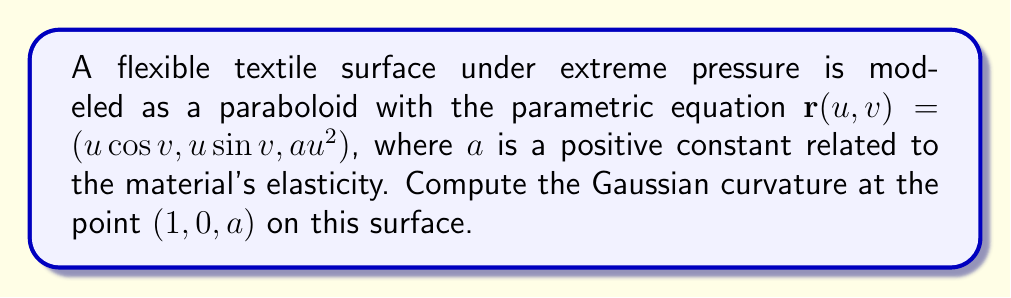What is the answer to this math problem? To compute the Gaussian curvature, we'll follow these steps:

1) First, we need to calculate the first fundamental form coefficients:
   $E = \mathbf{r}_u \cdot \mathbf{r}_u$, $F = \mathbf{r}_u \cdot \mathbf{r}_v$, $G = \mathbf{r}_v \cdot \mathbf{r}_v$

2) Then, we'll calculate the second fundamental form coefficients:
   $e = \mathbf{n} \cdot \mathbf{r}_{uu}$, $f = \mathbf{n} \cdot \mathbf{r}_{uv}$, $g = \mathbf{n} \cdot \mathbf{r}_{vv}$

3) Finally, we'll use the formula for Gaussian curvature:
   $K = \frac{eg-f^2}{EG-F^2}$

Step 1: Calculating first fundamental form coefficients

$\mathbf{r}_u = (\cos v, \sin v, 2au)$
$\mathbf{r}_v = (-u\sin v, u\cos v, 0)$

$E = \cos^2 v + \sin^2 v + 4a^2u^2 = 1 + 4a^2u^2$
$F = -u\sin v \cos v + u\sin v \cos v = 0$
$G = u^2\sin^2 v + u^2\cos^2 v = u^2$

Step 2: Calculating second fundamental form coefficients

$\mathbf{r}_{uu} = (0, 0, 2a)$
$\mathbf{r}_{uv} = (-\sin v, \cos v, 0)$
$\mathbf{r}_{vv} = (-u\cos v, -u\sin v, 0)$

The normal vector $\mathbf{n}$ is given by:
$\mathbf{n} = \frac{\mathbf{r}_u \times \mathbf{r}_v}{|\mathbf{r}_u \times \mathbf{r}_v|} = \frac{(-2au\cos v, -2au\sin v, u)}{\sqrt{u^2(1+4a^2u^2)}}$

Now we can calculate e, f, and g:

$e = \frac{2au}{\sqrt{u^2(1+4a^2u^2)}}$
$f = 0$
$g = \frac{u^3}{\sqrt{u^2(1+4a^2u^2)}}$

Step 3: Calculating Gaussian curvature

$K = \frac{eg-f^2}{EG-F^2} = \frac{2a^2u^4}{u^2(1+4a^2u^2)^2} = \frac{2a^2}{(1+4a^2u^2)^2}$

At the point $(1,0,a)$, $u=1$, so:

$K = \frac{2a^2}{(1+4a^2)^2}$

This is the Gaussian curvature at the specified point.
Answer: $$\frac{2a^2}{(1+4a^2)^2}$$ 